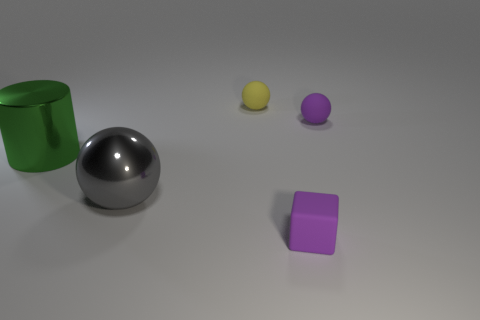Add 4 green shiny objects. How many objects exist? 9 Subtract all spheres. How many objects are left? 2 Subtract all green objects. Subtract all small yellow rubber objects. How many objects are left? 3 Add 1 yellow things. How many yellow things are left? 2 Add 2 large green objects. How many large green objects exist? 3 Subtract 0 yellow cylinders. How many objects are left? 5 